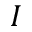<formula> <loc_0><loc_0><loc_500><loc_500>I</formula> 